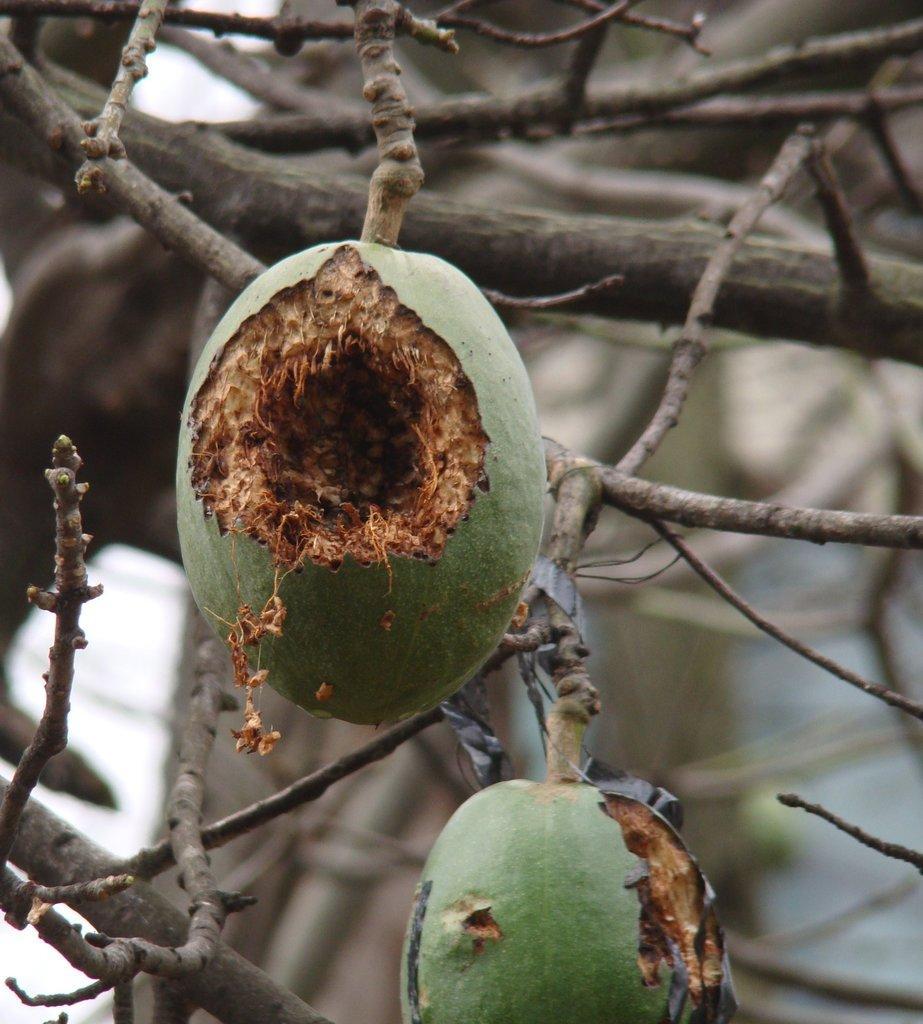Describe this image in one or two sentences. In this image, we can see some trees with fruits. 